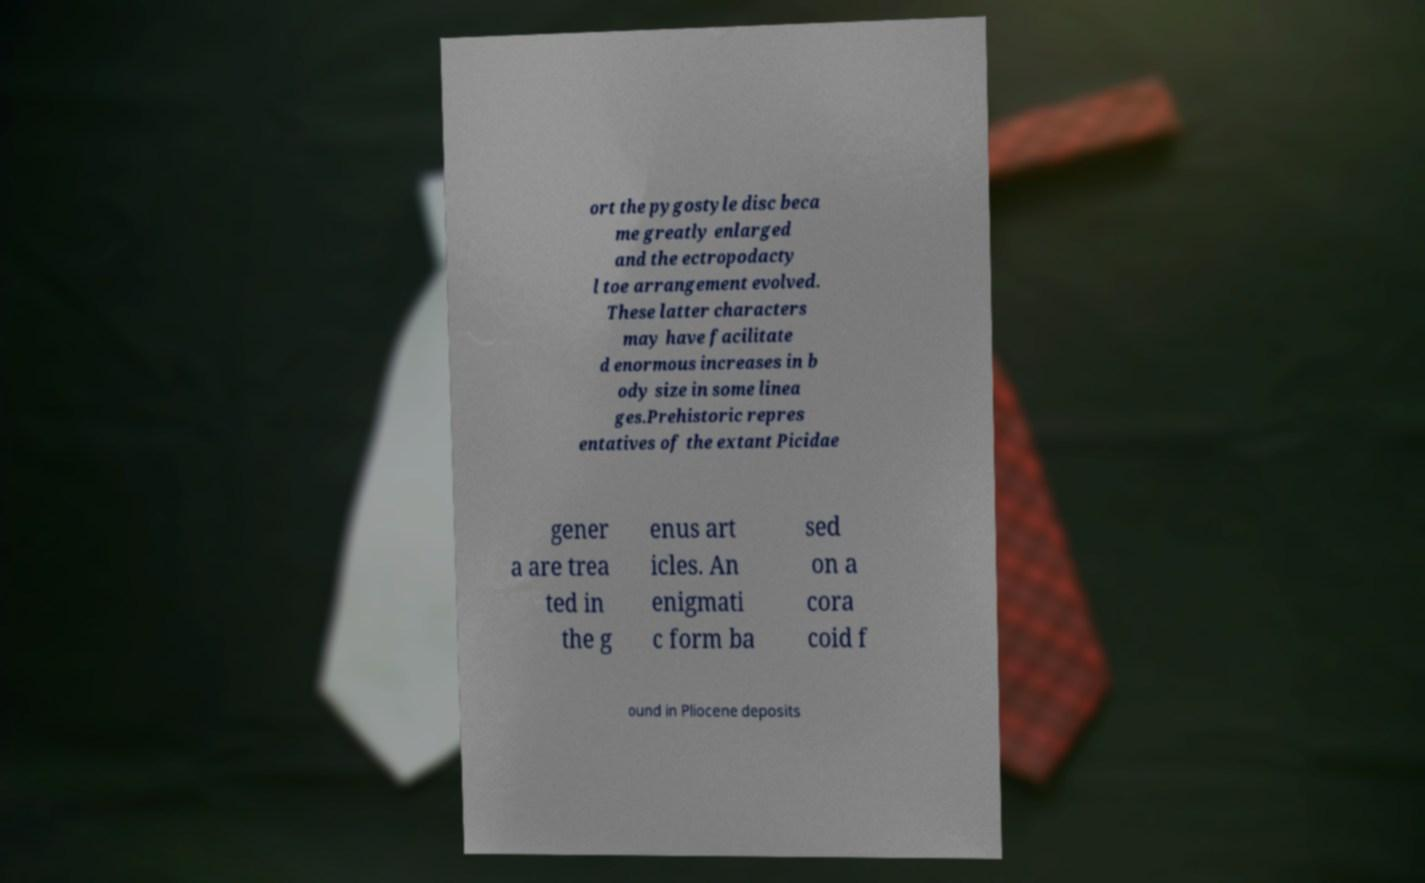Can you accurately transcribe the text from the provided image for me? ort the pygostyle disc beca me greatly enlarged and the ectropodacty l toe arrangement evolved. These latter characters may have facilitate d enormous increases in b ody size in some linea ges.Prehistoric repres entatives of the extant Picidae gener a are trea ted in the g enus art icles. An enigmati c form ba sed on a cora coid f ound in Pliocene deposits 